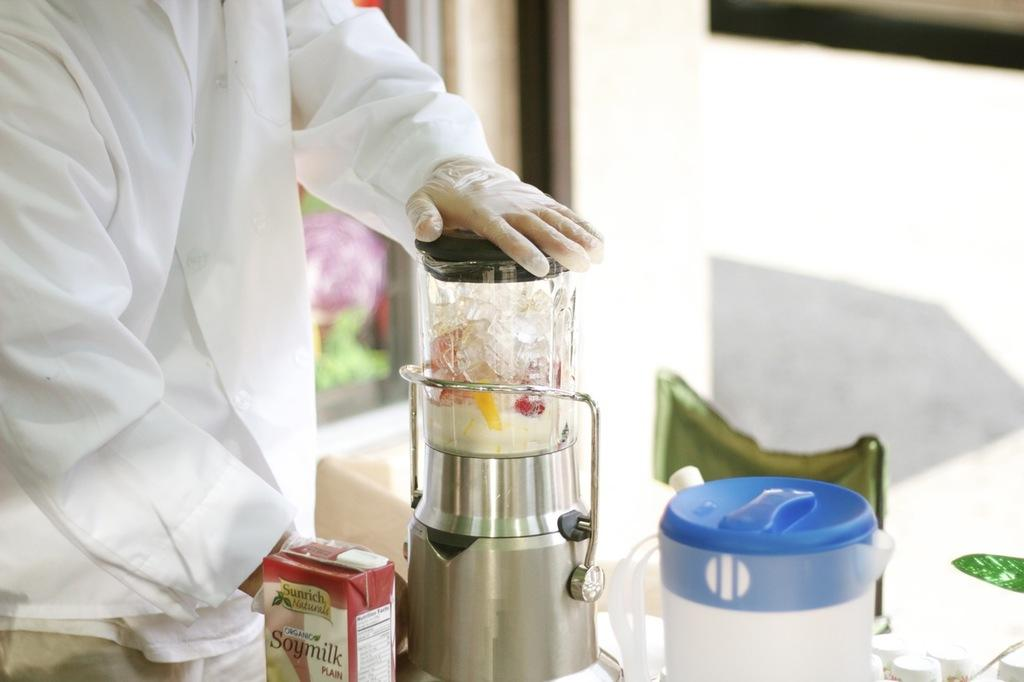<image>
Render a clear and concise summary of the photo. a man wearing a glove standing by a blender and a box that is labeled 'soymilk' 